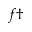<formula> <loc_0><loc_0><loc_500><loc_500>f \dagger</formula> 